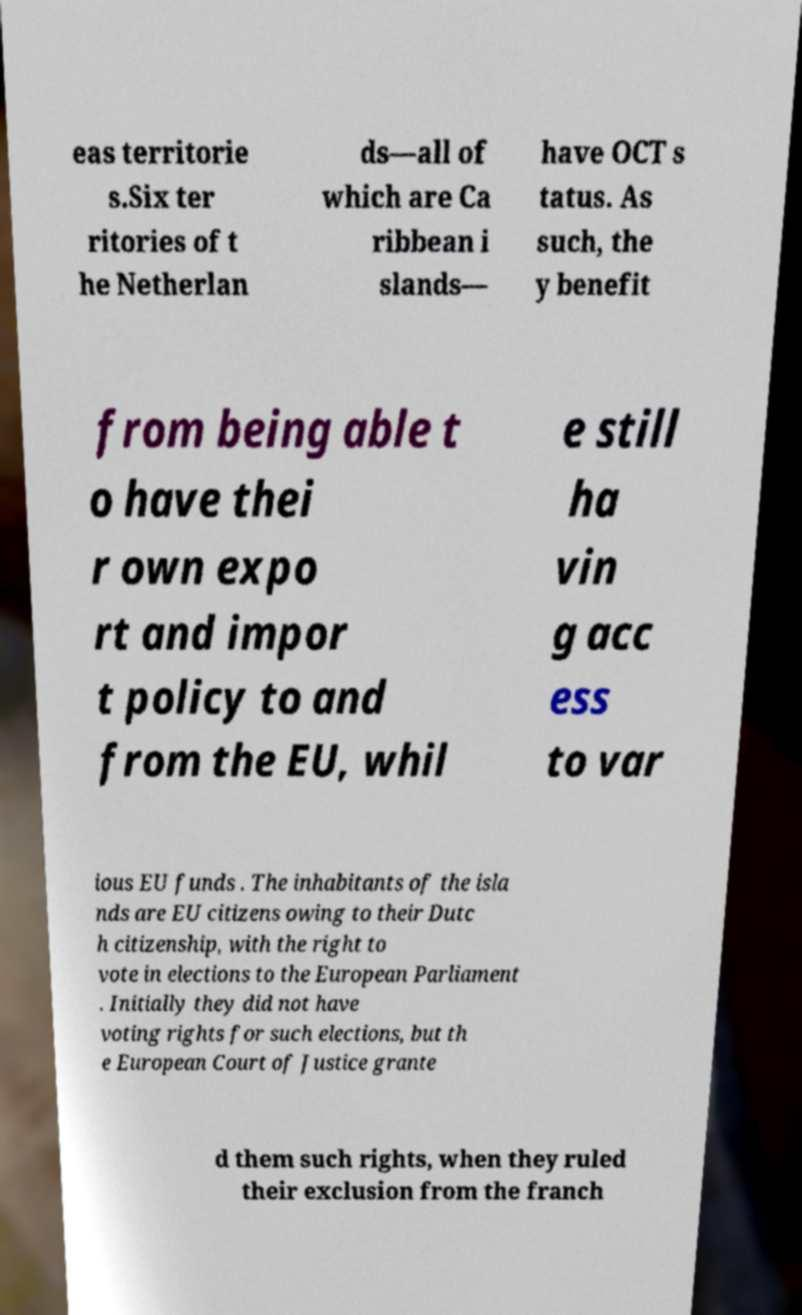I need the written content from this picture converted into text. Can you do that? eas territorie s.Six ter ritories of t he Netherlan ds—all of which are Ca ribbean i slands— have OCT s tatus. As such, the y benefit from being able t o have thei r own expo rt and impor t policy to and from the EU, whil e still ha vin g acc ess to var ious EU funds . The inhabitants of the isla nds are EU citizens owing to their Dutc h citizenship, with the right to vote in elections to the European Parliament . Initially they did not have voting rights for such elections, but th e European Court of Justice grante d them such rights, when they ruled their exclusion from the franch 